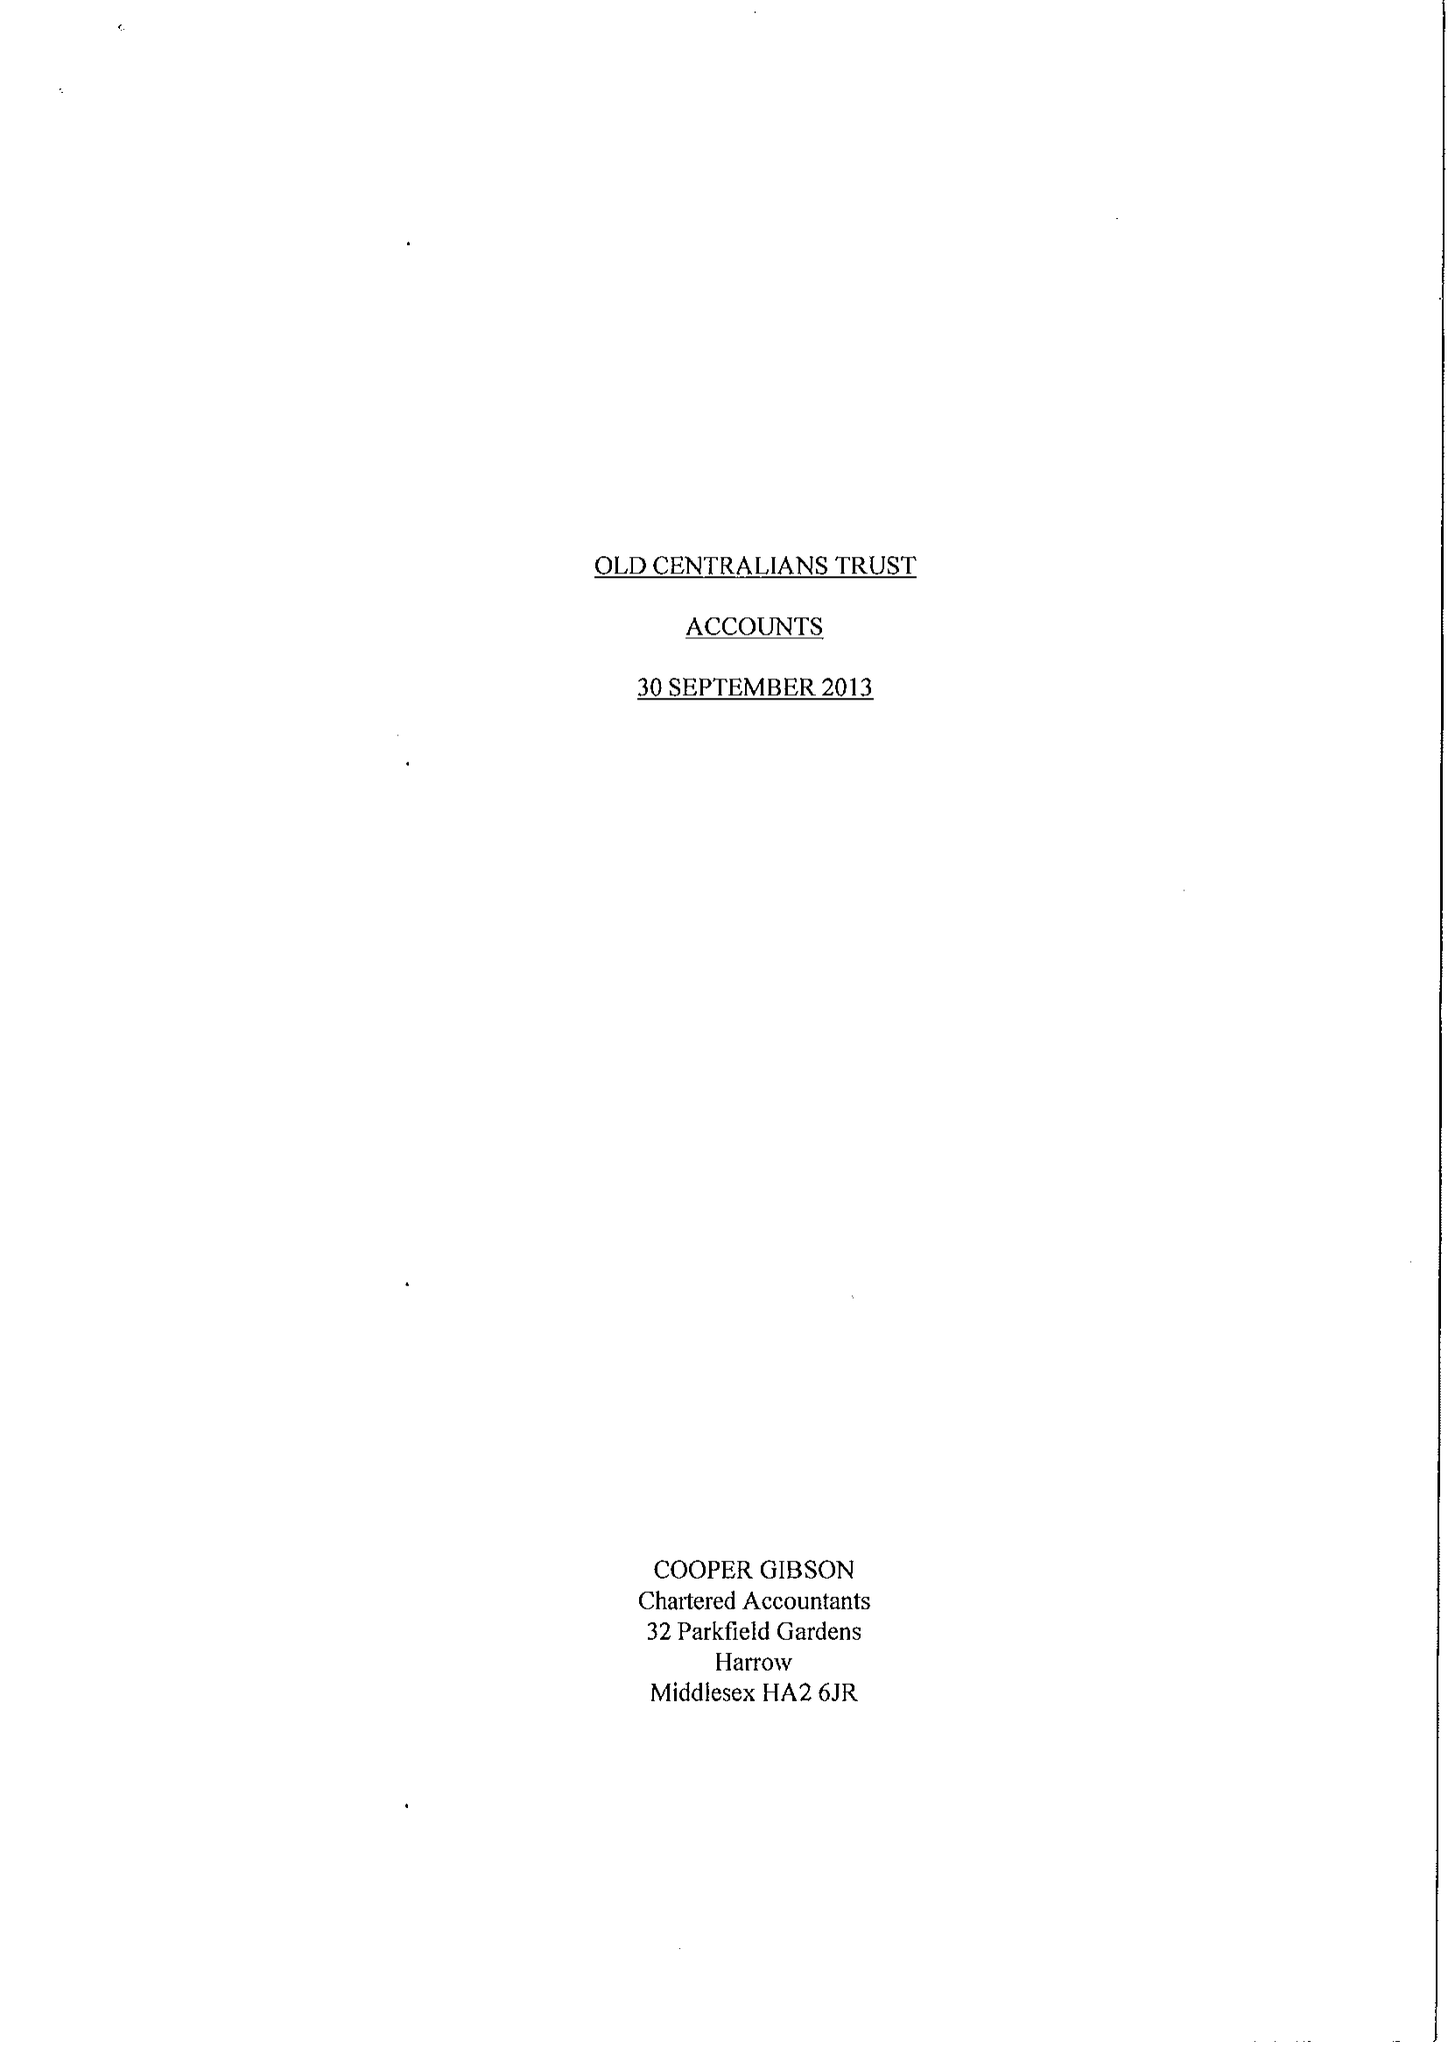What is the value for the address__postcode?
Answer the question using a single word or phrase. SW7 2AZ 